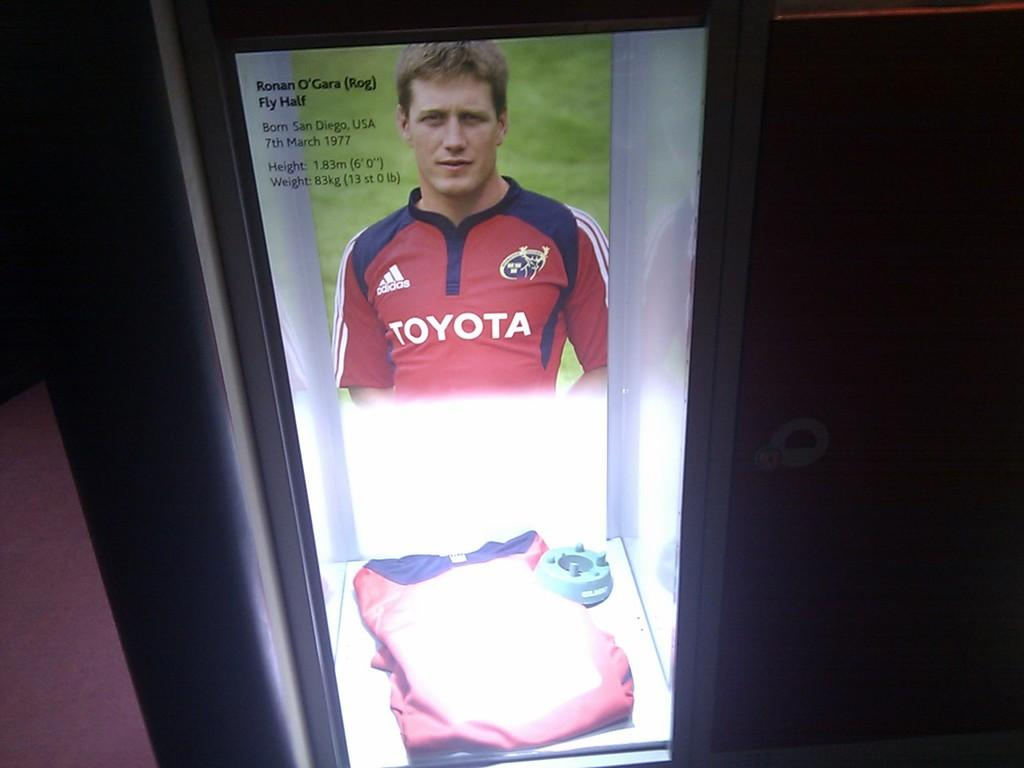<image>
Render a clear and concise summary of the photo. The guy in the picture is sponsored by Toyota and Adidas. 